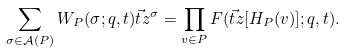Convert formula to latex. <formula><loc_0><loc_0><loc_500><loc_500>\sum _ { \sigma \in \mathcal { A } ( P ) } W _ { P } ( \sigma ; q , t ) \vec { t } z ^ { \sigma } = \prod _ { v \in P } F ( \vec { t } z [ H _ { P } ( v ) ] ; q , t ) .</formula> 